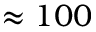Convert formula to latex. <formula><loc_0><loc_0><loc_500><loc_500>\approx 1 0 0</formula> 